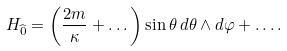<formula> <loc_0><loc_0><loc_500><loc_500>H _ { \widehat { 0 } } = \left ( { \frac { 2 m } { \kappa } } + \dots \right ) \sin \theta \, d \theta \wedge d \varphi + \dots .</formula> 